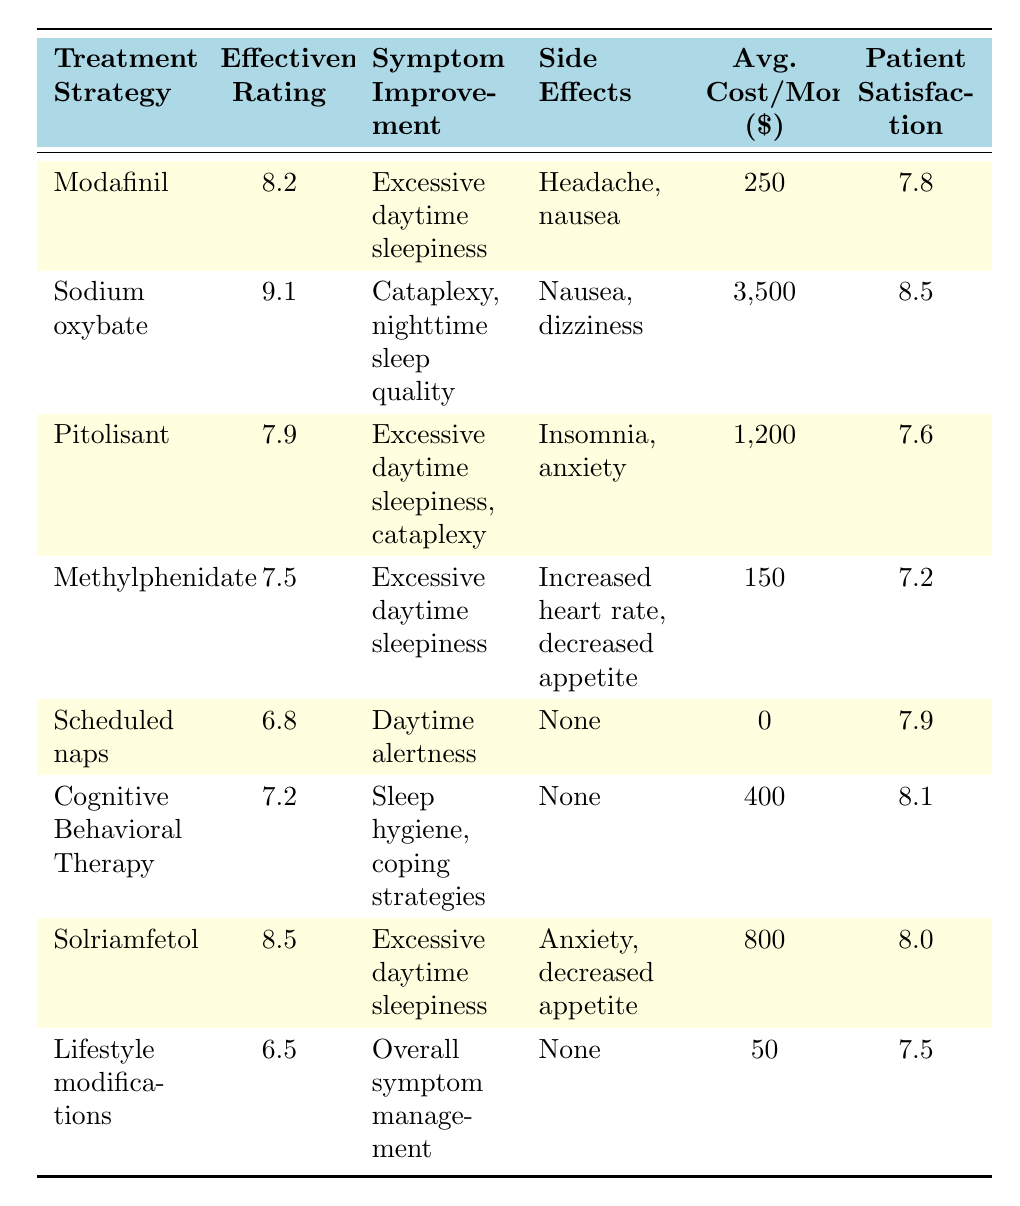What is the effectiveness rating of Sodium oxybate? The table shows that Sodium oxybate has an effectiveness rating listed as 9.1 specifically in the "Effectiveness Rating" column.
Answer: 9.1 Which treatment strategy has the highest patient satisfaction? By comparing the "Patient Satisfaction" values across all treatment strategies, Sodium oxybate has the highest rating at 8.5.
Answer: Sodium oxybate What is the average cost per month for Modafinil? The "Avg. Cost/Month" column lists Modafinil at a cost of 250.
Answer: 250 What is the difference in effectiveness rating between Solriamfetol and Cognitive Behavioral Therapy? Solriamfetol has an effectiveness rating of 8.5 and Cognitive Behavioral Therapy has a rating of 7.2, so the difference is 8.5 - 7.2 = 1.3.
Answer: 1.3 Is there any treatment strategy with no side effects? Scheduled naps, Cognitive Behavioral Therapy, and Lifestyle modifications show "None" listed under the "Side Effects" category. Therefore, yes, these treatment strategies have no side effects.
Answer: Yes What is the average patient satisfaction for treatment strategies that improve excessive daytime sleepiness? The relevant treatments are Modafinil (7.8), Pitolisant (7.6), Methylphenidate (7.2), and Solriamfetol (8.0). Summing their scores gives 7.8 + 7.6 + 7.2 + 8.0 = 30.6. Dividing by 4 treatments results in an average of 30.6 / 4 = 7.65.
Answer: 7.65 Which treatment has the lowest effectiveness rating? By reviewing the "Effectiveness Rating" column, Lifestyle modifications have the lowest rating at 6.5, making it the least effective option listed.
Answer: Lifestyle modifications What are the side effects of Pitolisant? The table states that the side effects listed for Pitolisant are insomnia and anxiety as shown in the "Side Effects" column.
Answer: Insomnia, anxiety How much more does Sodium oxybate cost per month compared to Scheduled naps? Sodium oxybate costs 3,500 and Scheduled naps cost 0. The difference is 3,500 - 0 = 3,500.
Answer: 3,500 Which treatment strategy has the broadest range of symptom improvement? Sodium oxybate mentions both cataplexy and nighttime sleep quality, while Pitolisant mentions both excessive daytime sleepiness and cataplexy. Sodium oxybate's combination makes it the broadest in the context of those mentioned symptoms.
Answer: Sodium oxybate 